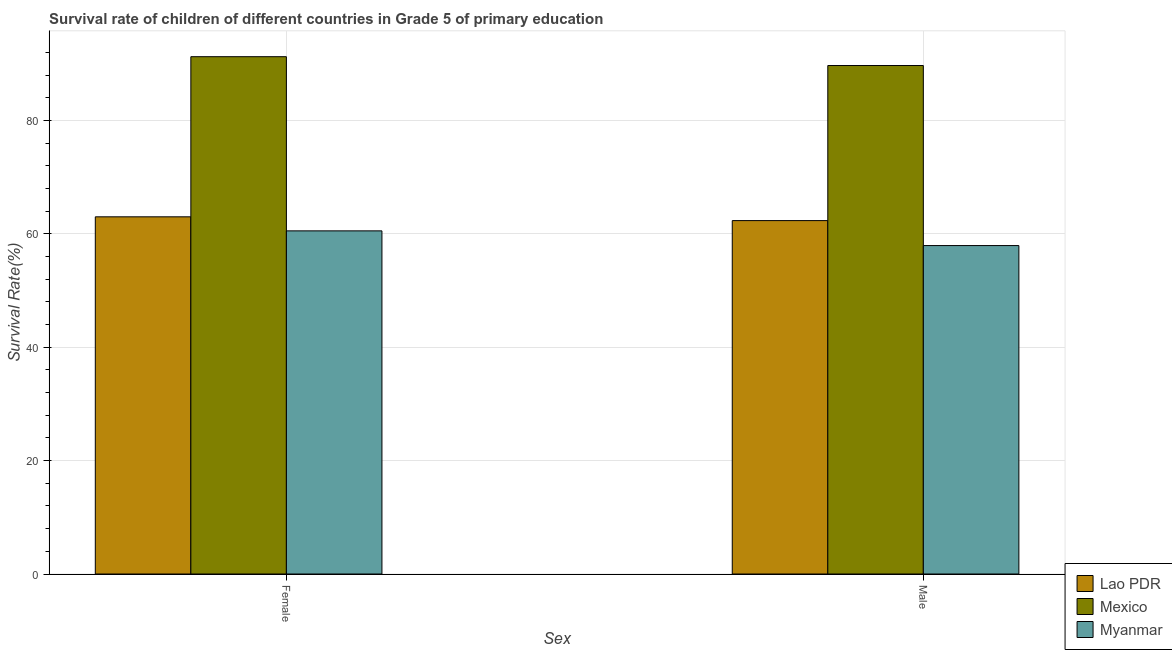How many different coloured bars are there?
Give a very brief answer. 3. How many groups of bars are there?
Your answer should be compact. 2. Are the number of bars on each tick of the X-axis equal?
Keep it short and to the point. Yes. How many bars are there on the 2nd tick from the right?
Ensure brevity in your answer.  3. What is the survival rate of female students in primary education in Myanmar?
Ensure brevity in your answer.  60.54. Across all countries, what is the maximum survival rate of female students in primary education?
Your answer should be compact. 91.27. Across all countries, what is the minimum survival rate of female students in primary education?
Ensure brevity in your answer.  60.54. In which country was the survival rate of male students in primary education maximum?
Offer a terse response. Mexico. In which country was the survival rate of female students in primary education minimum?
Offer a terse response. Myanmar. What is the total survival rate of male students in primary education in the graph?
Provide a short and direct response. 210.01. What is the difference between the survival rate of female students in primary education in Lao PDR and that in Mexico?
Provide a succinct answer. -28.25. What is the difference between the survival rate of female students in primary education in Mexico and the survival rate of male students in primary education in Myanmar?
Your response must be concise. 33.32. What is the average survival rate of female students in primary education per country?
Your response must be concise. 71.61. What is the difference between the survival rate of male students in primary education and survival rate of female students in primary education in Myanmar?
Make the answer very short. -2.6. What is the ratio of the survival rate of female students in primary education in Myanmar to that in Mexico?
Your answer should be very brief. 0.66. Is the survival rate of male students in primary education in Mexico less than that in Myanmar?
Your answer should be compact. No. What does the 3rd bar from the left in Male represents?
Ensure brevity in your answer.  Myanmar. How many bars are there?
Ensure brevity in your answer.  6. Does the graph contain any zero values?
Offer a terse response. No. Where does the legend appear in the graph?
Your answer should be compact. Bottom right. How are the legend labels stacked?
Provide a succinct answer. Vertical. What is the title of the graph?
Ensure brevity in your answer.  Survival rate of children of different countries in Grade 5 of primary education. Does "Egypt, Arab Rep." appear as one of the legend labels in the graph?
Your response must be concise. No. What is the label or title of the X-axis?
Keep it short and to the point. Sex. What is the label or title of the Y-axis?
Make the answer very short. Survival Rate(%). What is the Survival Rate(%) of Lao PDR in Female?
Ensure brevity in your answer.  63.02. What is the Survival Rate(%) in Mexico in Female?
Offer a very short reply. 91.27. What is the Survival Rate(%) of Myanmar in Female?
Give a very brief answer. 60.54. What is the Survival Rate(%) in Lao PDR in Male?
Your answer should be compact. 62.35. What is the Survival Rate(%) of Mexico in Male?
Your response must be concise. 89.71. What is the Survival Rate(%) in Myanmar in Male?
Provide a succinct answer. 57.94. Across all Sex, what is the maximum Survival Rate(%) in Lao PDR?
Make the answer very short. 63.02. Across all Sex, what is the maximum Survival Rate(%) of Mexico?
Offer a terse response. 91.27. Across all Sex, what is the maximum Survival Rate(%) in Myanmar?
Provide a short and direct response. 60.54. Across all Sex, what is the minimum Survival Rate(%) of Lao PDR?
Offer a very short reply. 62.35. Across all Sex, what is the minimum Survival Rate(%) in Mexico?
Your answer should be compact. 89.71. Across all Sex, what is the minimum Survival Rate(%) of Myanmar?
Your response must be concise. 57.94. What is the total Survival Rate(%) in Lao PDR in the graph?
Provide a short and direct response. 125.37. What is the total Survival Rate(%) in Mexico in the graph?
Offer a very short reply. 180.98. What is the total Survival Rate(%) of Myanmar in the graph?
Provide a succinct answer. 118.48. What is the difference between the Survival Rate(%) of Lao PDR in Female and that in Male?
Make the answer very short. 0.67. What is the difference between the Survival Rate(%) of Mexico in Female and that in Male?
Offer a very short reply. 1.56. What is the difference between the Survival Rate(%) in Myanmar in Female and that in Male?
Offer a terse response. 2.6. What is the difference between the Survival Rate(%) of Lao PDR in Female and the Survival Rate(%) of Mexico in Male?
Your answer should be compact. -26.69. What is the difference between the Survival Rate(%) in Lao PDR in Female and the Survival Rate(%) in Myanmar in Male?
Offer a very short reply. 5.07. What is the difference between the Survival Rate(%) in Mexico in Female and the Survival Rate(%) in Myanmar in Male?
Offer a very short reply. 33.32. What is the average Survival Rate(%) in Lao PDR per Sex?
Your response must be concise. 62.68. What is the average Survival Rate(%) in Mexico per Sex?
Your answer should be compact. 90.49. What is the average Survival Rate(%) in Myanmar per Sex?
Provide a succinct answer. 59.24. What is the difference between the Survival Rate(%) of Lao PDR and Survival Rate(%) of Mexico in Female?
Offer a terse response. -28.25. What is the difference between the Survival Rate(%) of Lao PDR and Survival Rate(%) of Myanmar in Female?
Your response must be concise. 2.48. What is the difference between the Survival Rate(%) in Mexico and Survival Rate(%) in Myanmar in Female?
Make the answer very short. 30.73. What is the difference between the Survival Rate(%) in Lao PDR and Survival Rate(%) in Mexico in Male?
Your response must be concise. -27.36. What is the difference between the Survival Rate(%) in Lao PDR and Survival Rate(%) in Myanmar in Male?
Give a very brief answer. 4.41. What is the difference between the Survival Rate(%) in Mexico and Survival Rate(%) in Myanmar in Male?
Your answer should be very brief. 31.77. What is the ratio of the Survival Rate(%) in Lao PDR in Female to that in Male?
Keep it short and to the point. 1.01. What is the ratio of the Survival Rate(%) in Mexico in Female to that in Male?
Your answer should be very brief. 1.02. What is the ratio of the Survival Rate(%) of Myanmar in Female to that in Male?
Your answer should be compact. 1.04. What is the difference between the highest and the second highest Survival Rate(%) in Lao PDR?
Your response must be concise. 0.67. What is the difference between the highest and the second highest Survival Rate(%) of Mexico?
Keep it short and to the point. 1.56. What is the difference between the highest and the second highest Survival Rate(%) of Myanmar?
Provide a succinct answer. 2.6. What is the difference between the highest and the lowest Survival Rate(%) of Lao PDR?
Keep it short and to the point. 0.67. What is the difference between the highest and the lowest Survival Rate(%) of Mexico?
Your response must be concise. 1.56. What is the difference between the highest and the lowest Survival Rate(%) in Myanmar?
Provide a short and direct response. 2.6. 